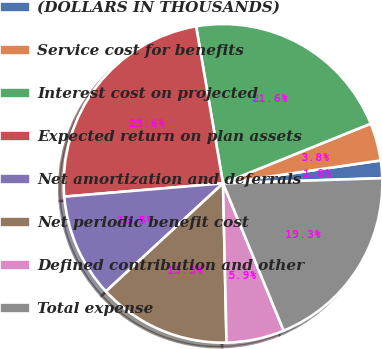Convert chart. <chart><loc_0><loc_0><loc_500><loc_500><pie_chart><fcel>(DOLLARS IN THOUSANDS)<fcel>Service cost for benefits<fcel>Interest cost on projected<fcel>Expected return on plan assets<fcel>Net amortization and deferrals<fcel>Net periodic benefit cost<fcel>Defined contribution and other<fcel>Total expense<nl><fcel>1.78%<fcel>3.82%<fcel>21.59%<fcel>23.63%<fcel>10.53%<fcel>13.49%<fcel>5.87%<fcel>19.3%<nl></chart> 